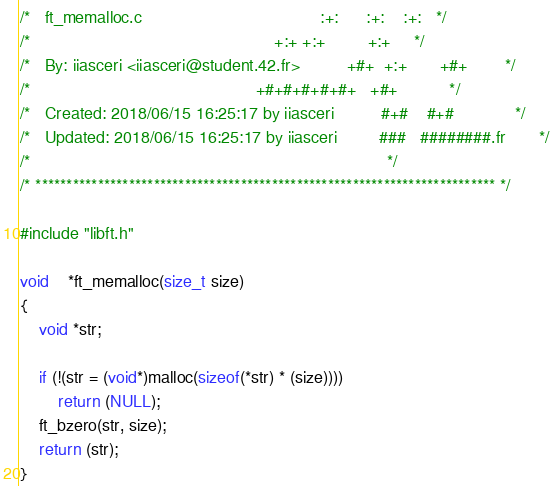Convert code to text. <code><loc_0><loc_0><loc_500><loc_500><_C_>/*   ft_memalloc.c                                      :+:      :+:    :+:   */
/*                                                    +:+ +:+         +:+     */
/*   By: iiasceri <iiasceri@student.42.fr>          +#+  +:+       +#+        */
/*                                                +#+#+#+#+#+   +#+           */
/*   Created: 2018/06/15 16:25:17 by iiasceri          #+#    #+#             */
/*   Updated: 2018/06/15 16:25:17 by iiasceri         ###   ########.fr       */
/*                                                                            */
/* ************************************************************************** */

#include "libft.h"

void	*ft_memalloc(size_t size)
{
	void *str;

	if (!(str = (void*)malloc(sizeof(*str) * (size))))
		return (NULL);
	ft_bzero(str, size);
	return (str);
}
</code> 